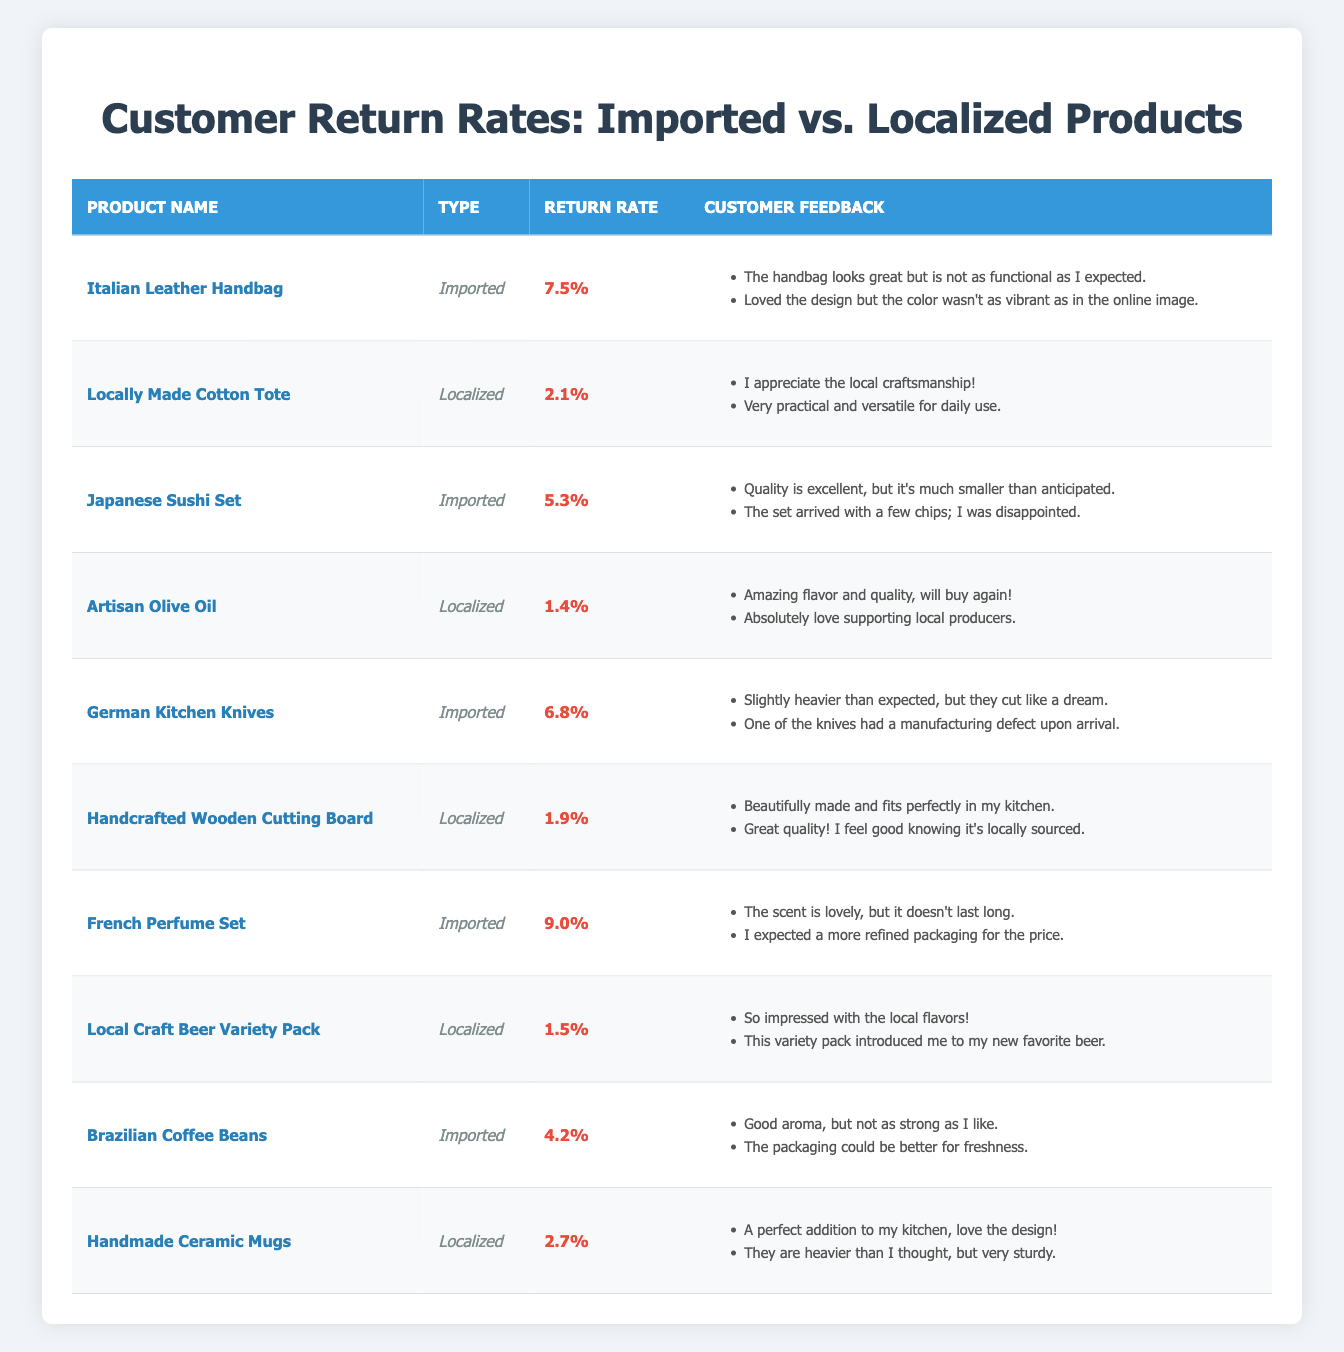What is the return rate for the Italian Leather Handbag? The return rate for this product is listed in the table under the "Return Rate" column for the corresponding row. It is specifically noted as 7.5%.
Answer: 7.5% Which localized product has the lowest return rate? By examining the return rates of all localized products, Artisan Olive Oil has a return rate of 1.4%, which is the lowest among them.
Answer: Artisan Olive Oil How many imported products have a return rate higher than 6%? Looking through the table, the imported products with return rates above 6% are Italian Leather Handbag (7.5%), German Kitchen Knives (6.8%), and French Perfume Set (9.0%). Thus, there are three such products.
Answer: 3 Is the return rate for Local Craft Beer Variety Pack lower than that of Brazilian Coffee Beans? The return rate for Local Craft Beer Variety Pack is 1.5%, while the return rate for Brazilian Coffee Beans is 4.2%. Since 1.5% is less than 4.2%, the answer is yes.
Answer: Yes What is the average return rate for all localized products? First, we list the return rates of localized products: 2.1%, 1.4%, 1.9%, 1.5%, 2.7%. We sum these values (2.1 + 1.4 + 1.9 + 1.5 + 2.7 = 9.6) and divide by the number of localized products, which is 5. Therefore, the average return rate is 9.6 / 5 = 1.92%.
Answer: 1.92% Which product has customer feedback mentioning "local craftsmanship"? By searching the customer feedback for each product, the phrase "local craftsmanship" appears in the feedback for the Locally Made Cotton Tote.
Answer: Locally Made Cotton Tote Are there any imported products with customer feedback that mentions "disappointed"? Checking the customer feedback for each imported product, the Japanese Sushi Set includes a comment stating "The set arrived with a few chips; I was disappointed." Thus, there is at least one product that matches this criterion.
Answer: Yes What is the difference between the return rate of the French Perfume Set and the Handcrafted Wooden Cutting Board? The return rate for the French Perfume Set is 9.0%, and for the Handcrafted Wooden Cutting Board, it is 1.9%. The difference can be calculated as 9.0 - 1.9 = 7.1%.
Answer: 7.1% 